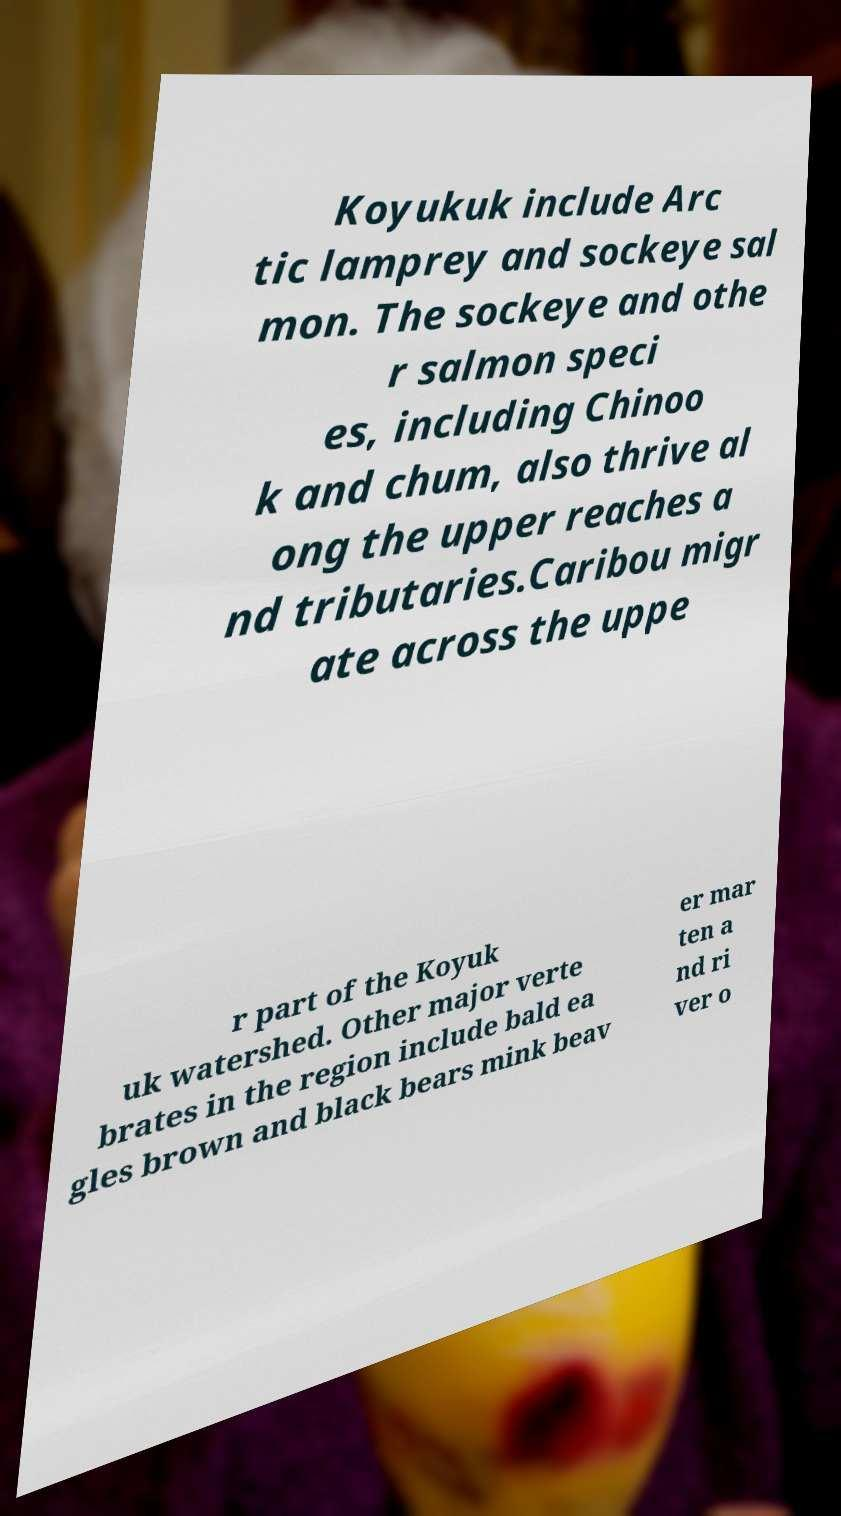What messages or text are displayed in this image? I need them in a readable, typed format. Koyukuk include Arc tic lamprey and sockeye sal mon. The sockeye and othe r salmon speci es, including Chinoo k and chum, also thrive al ong the upper reaches a nd tributaries.Caribou migr ate across the uppe r part of the Koyuk uk watershed. Other major verte brates in the region include bald ea gles brown and black bears mink beav er mar ten a nd ri ver o 